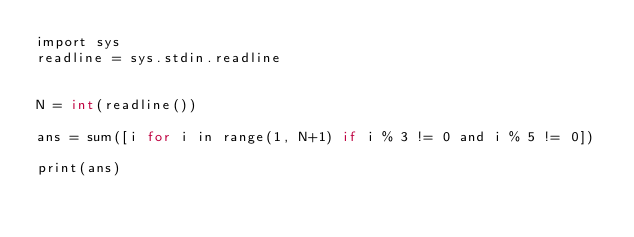<code> <loc_0><loc_0><loc_500><loc_500><_C_>import sys
readline = sys.stdin.readline


N = int(readline())

ans = sum([i for i in range(1, N+1) if i % 3 != 0 and i % 5 != 0])

print(ans)

</code> 